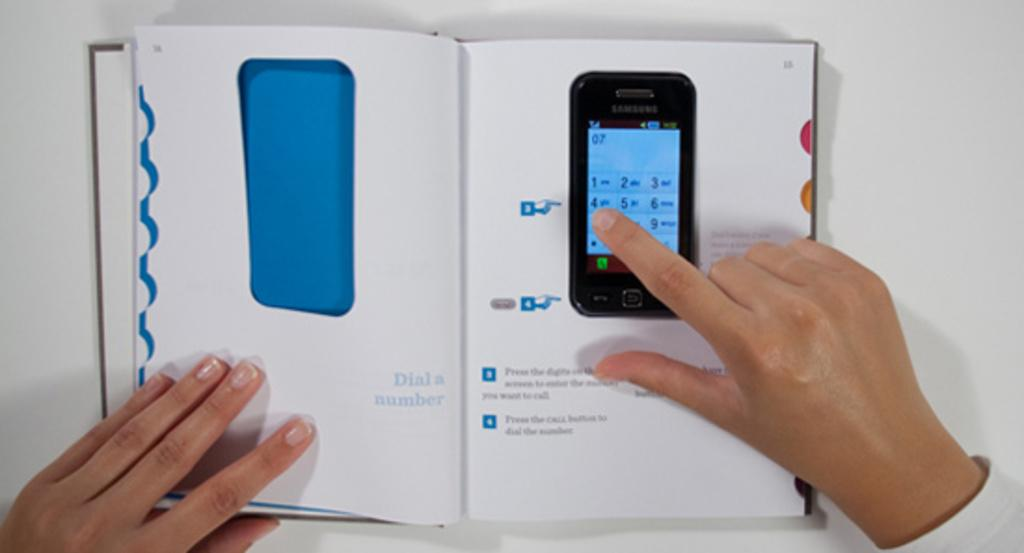Provide a one-sentence caption for the provided image. A hand hovers over the 4 of a Samsung phone. 